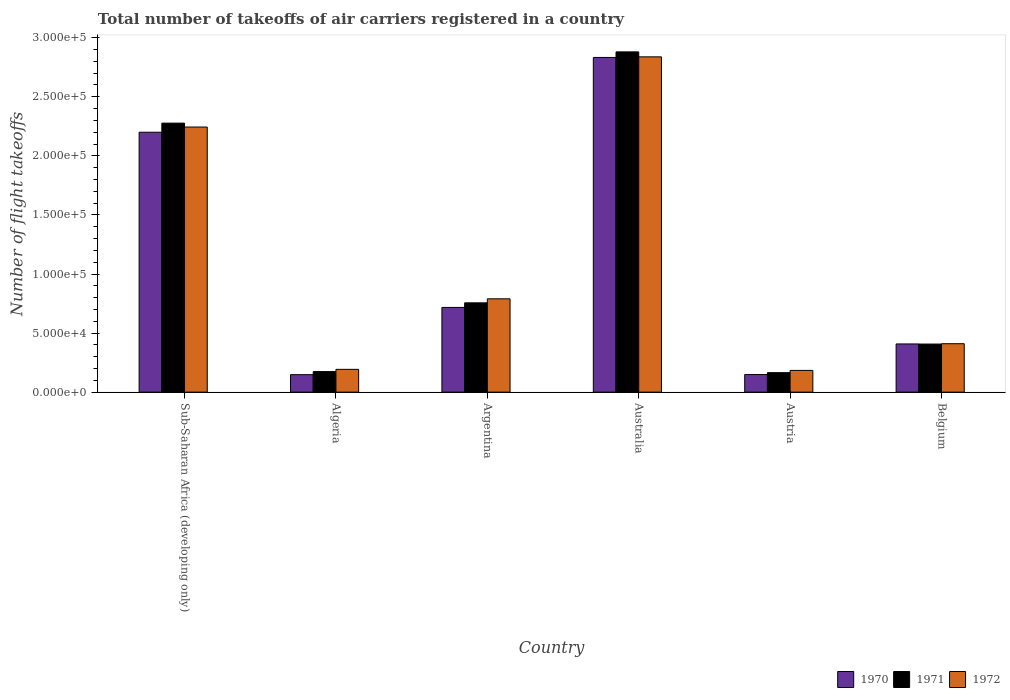How many different coloured bars are there?
Offer a terse response. 3. How many bars are there on the 1st tick from the left?
Provide a succinct answer. 3. What is the label of the 2nd group of bars from the left?
Ensure brevity in your answer.  Algeria. In how many cases, is the number of bars for a given country not equal to the number of legend labels?
Ensure brevity in your answer.  0. What is the total number of flight takeoffs in 1970 in Austria?
Your response must be concise. 1.49e+04. Across all countries, what is the maximum total number of flight takeoffs in 1972?
Ensure brevity in your answer.  2.84e+05. Across all countries, what is the minimum total number of flight takeoffs in 1971?
Make the answer very short. 1.65e+04. In which country was the total number of flight takeoffs in 1971 maximum?
Provide a short and direct response. Australia. What is the total total number of flight takeoffs in 1972 in the graph?
Your answer should be very brief. 6.66e+05. What is the difference between the total number of flight takeoffs in 1970 in Argentina and that in Belgium?
Provide a short and direct response. 3.09e+04. What is the difference between the total number of flight takeoffs in 1970 in Sub-Saharan Africa (developing only) and the total number of flight takeoffs in 1971 in Austria?
Offer a very short reply. 2.04e+05. What is the average total number of flight takeoffs in 1970 per country?
Provide a succinct answer. 1.08e+05. What is the difference between the total number of flight takeoffs of/in 1972 and total number of flight takeoffs of/in 1971 in Argentina?
Your answer should be compact. 3400. What is the ratio of the total number of flight takeoffs in 1971 in Argentina to that in Belgium?
Provide a short and direct response. 1.86. Is the total number of flight takeoffs in 1970 in Australia less than that in Belgium?
Ensure brevity in your answer.  No. What is the difference between the highest and the second highest total number of flight takeoffs in 1972?
Provide a succinct answer. 5.94e+04. What is the difference between the highest and the lowest total number of flight takeoffs in 1970?
Offer a very short reply. 2.68e+05. In how many countries, is the total number of flight takeoffs in 1972 greater than the average total number of flight takeoffs in 1972 taken over all countries?
Give a very brief answer. 2. Is the sum of the total number of flight takeoffs in 1971 in Australia and Belgium greater than the maximum total number of flight takeoffs in 1972 across all countries?
Offer a very short reply. Yes. Are all the bars in the graph horizontal?
Ensure brevity in your answer.  No. Does the graph contain any zero values?
Provide a short and direct response. No. Does the graph contain grids?
Make the answer very short. No. Where does the legend appear in the graph?
Your response must be concise. Bottom right. How are the legend labels stacked?
Offer a terse response. Horizontal. What is the title of the graph?
Give a very brief answer. Total number of takeoffs of air carriers registered in a country. What is the label or title of the X-axis?
Provide a short and direct response. Country. What is the label or title of the Y-axis?
Make the answer very short. Number of flight takeoffs. What is the Number of flight takeoffs of 1970 in Sub-Saharan Africa (developing only)?
Your answer should be compact. 2.20e+05. What is the Number of flight takeoffs of 1971 in Sub-Saharan Africa (developing only)?
Offer a very short reply. 2.28e+05. What is the Number of flight takeoffs of 1972 in Sub-Saharan Africa (developing only)?
Your answer should be very brief. 2.24e+05. What is the Number of flight takeoffs in 1970 in Algeria?
Ensure brevity in your answer.  1.48e+04. What is the Number of flight takeoffs in 1971 in Algeria?
Offer a very short reply. 1.74e+04. What is the Number of flight takeoffs of 1972 in Algeria?
Give a very brief answer. 1.93e+04. What is the Number of flight takeoffs of 1970 in Argentina?
Keep it short and to the point. 7.17e+04. What is the Number of flight takeoffs of 1971 in Argentina?
Provide a succinct answer. 7.56e+04. What is the Number of flight takeoffs of 1972 in Argentina?
Your answer should be very brief. 7.90e+04. What is the Number of flight takeoffs of 1970 in Australia?
Make the answer very short. 2.83e+05. What is the Number of flight takeoffs of 1971 in Australia?
Provide a succinct answer. 2.88e+05. What is the Number of flight takeoffs of 1972 in Australia?
Provide a short and direct response. 2.84e+05. What is the Number of flight takeoffs of 1970 in Austria?
Provide a succinct answer. 1.49e+04. What is the Number of flight takeoffs in 1971 in Austria?
Your answer should be very brief. 1.65e+04. What is the Number of flight takeoffs of 1972 in Austria?
Provide a short and direct response. 1.84e+04. What is the Number of flight takeoffs of 1970 in Belgium?
Keep it short and to the point. 4.08e+04. What is the Number of flight takeoffs in 1971 in Belgium?
Your response must be concise. 4.07e+04. What is the Number of flight takeoffs of 1972 in Belgium?
Ensure brevity in your answer.  4.10e+04. Across all countries, what is the maximum Number of flight takeoffs in 1970?
Give a very brief answer. 2.83e+05. Across all countries, what is the maximum Number of flight takeoffs in 1971?
Ensure brevity in your answer.  2.88e+05. Across all countries, what is the maximum Number of flight takeoffs of 1972?
Give a very brief answer. 2.84e+05. Across all countries, what is the minimum Number of flight takeoffs in 1970?
Make the answer very short. 1.48e+04. Across all countries, what is the minimum Number of flight takeoffs in 1971?
Offer a very short reply. 1.65e+04. Across all countries, what is the minimum Number of flight takeoffs in 1972?
Your answer should be compact. 1.84e+04. What is the total Number of flight takeoffs in 1970 in the graph?
Offer a very short reply. 6.46e+05. What is the total Number of flight takeoffs of 1971 in the graph?
Your answer should be very brief. 6.66e+05. What is the total Number of flight takeoffs in 1972 in the graph?
Provide a succinct answer. 6.66e+05. What is the difference between the Number of flight takeoffs of 1970 in Sub-Saharan Africa (developing only) and that in Algeria?
Provide a succinct answer. 2.05e+05. What is the difference between the Number of flight takeoffs in 1971 in Sub-Saharan Africa (developing only) and that in Algeria?
Offer a terse response. 2.10e+05. What is the difference between the Number of flight takeoffs in 1972 in Sub-Saharan Africa (developing only) and that in Algeria?
Give a very brief answer. 2.05e+05. What is the difference between the Number of flight takeoffs of 1970 in Sub-Saharan Africa (developing only) and that in Argentina?
Give a very brief answer. 1.48e+05. What is the difference between the Number of flight takeoffs in 1971 in Sub-Saharan Africa (developing only) and that in Argentina?
Your response must be concise. 1.52e+05. What is the difference between the Number of flight takeoffs of 1972 in Sub-Saharan Africa (developing only) and that in Argentina?
Make the answer very short. 1.45e+05. What is the difference between the Number of flight takeoffs of 1970 in Sub-Saharan Africa (developing only) and that in Australia?
Give a very brief answer. -6.33e+04. What is the difference between the Number of flight takeoffs of 1971 in Sub-Saharan Africa (developing only) and that in Australia?
Offer a very short reply. -6.03e+04. What is the difference between the Number of flight takeoffs of 1972 in Sub-Saharan Africa (developing only) and that in Australia?
Provide a short and direct response. -5.94e+04. What is the difference between the Number of flight takeoffs in 1970 in Sub-Saharan Africa (developing only) and that in Austria?
Make the answer very short. 2.05e+05. What is the difference between the Number of flight takeoffs in 1971 in Sub-Saharan Africa (developing only) and that in Austria?
Your answer should be very brief. 2.11e+05. What is the difference between the Number of flight takeoffs in 1972 in Sub-Saharan Africa (developing only) and that in Austria?
Your answer should be very brief. 2.06e+05. What is the difference between the Number of flight takeoffs of 1970 in Sub-Saharan Africa (developing only) and that in Belgium?
Your response must be concise. 1.79e+05. What is the difference between the Number of flight takeoffs of 1971 in Sub-Saharan Africa (developing only) and that in Belgium?
Make the answer very short. 1.87e+05. What is the difference between the Number of flight takeoffs in 1972 in Sub-Saharan Africa (developing only) and that in Belgium?
Your answer should be very brief. 1.83e+05. What is the difference between the Number of flight takeoffs of 1970 in Algeria and that in Argentina?
Provide a succinct answer. -5.69e+04. What is the difference between the Number of flight takeoffs in 1971 in Algeria and that in Argentina?
Ensure brevity in your answer.  -5.82e+04. What is the difference between the Number of flight takeoffs in 1972 in Algeria and that in Argentina?
Ensure brevity in your answer.  -5.97e+04. What is the difference between the Number of flight takeoffs of 1970 in Algeria and that in Australia?
Your answer should be very brief. -2.68e+05. What is the difference between the Number of flight takeoffs of 1971 in Algeria and that in Australia?
Your answer should be compact. -2.71e+05. What is the difference between the Number of flight takeoffs in 1972 in Algeria and that in Australia?
Your response must be concise. -2.64e+05. What is the difference between the Number of flight takeoffs of 1970 in Algeria and that in Austria?
Your answer should be compact. -100. What is the difference between the Number of flight takeoffs in 1971 in Algeria and that in Austria?
Provide a succinct answer. 900. What is the difference between the Number of flight takeoffs of 1972 in Algeria and that in Austria?
Keep it short and to the point. 900. What is the difference between the Number of flight takeoffs in 1970 in Algeria and that in Belgium?
Ensure brevity in your answer.  -2.60e+04. What is the difference between the Number of flight takeoffs in 1971 in Algeria and that in Belgium?
Your answer should be compact. -2.33e+04. What is the difference between the Number of flight takeoffs of 1972 in Algeria and that in Belgium?
Offer a terse response. -2.17e+04. What is the difference between the Number of flight takeoffs of 1970 in Argentina and that in Australia?
Keep it short and to the point. -2.12e+05. What is the difference between the Number of flight takeoffs of 1971 in Argentina and that in Australia?
Provide a short and direct response. -2.12e+05. What is the difference between the Number of flight takeoffs in 1972 in Argentina and that in Australia?
Ensure brevity in your answer.  -2.05e+05. What is the difference between the Number of flight takeoffs in 1970 in Argentina and that in Austria?
Provide a short and direct response. 5.68e+04. What is the difference between the Number of flight takeoffs of 1971 in Argentina and that in Austria?
Offer a terse response. 5.91e+04. What is the difference between the Number of flight takeoffs in 1972 in Argentina and that in Austria?
Provide a succinct answer. 6.06e+04. What is the difference between the Number of flight takeoffs in 1970 in Argentina and that in Belgium?
Keep it short and to the point. 3.09e+04. What is the difference between the Number of flight takeoffs in 1971 in Argentina and that in Belgium?
Ensure brevity in your answer.  3.49e+04. What is the difference between the Number of flight takeoffs of 1972 in Argentina and that in Belgium?
Keep it short and to the point. 3.80e+04. What is the difference between the Number of flight takeoffs of 1970 in Australia and that in Austria?
Keep it short and to the point. 2.68e+05. What is the difference between the Number of flight takeoffs of 1971 in Australia and that in Austria?
Offer a terse response. 2.72e+05. What is the difference between the Number of flight takeoffs in 1972 in Australia and that in Austria?
Your answer should be very brief. 2.65e+05. What is the difference between the Number of flight takeoffs in 1970 in Australia and that in Belgium?
Make the answer very short. 2.42e+05. What is the difference between the Number of flight takeoffs of 1971 in Australia and that in Belgium?
Provide a short and direct response. 2.47e+05. What is the difference between the Number of flight takeoffs of 1972 in Australia and that in Belgium?
Provide a short and direct response. 2.43e+05. What is the difference between the Number of flight takeoffs of 1970 in Austria and that in Belgium?
Your response must be concise. -2.59e+04. What is the difference between the Number of flight takeoffs of 1971 in Austria and that in Belgium?
Offer a terse response. -2.42e+04. What is the difference between the Number of flight takeoffs in 1972 in Austria and that in Belgium?
Offer a terse response. -2.26e+04. What is the difference between the Number of flight takeoffs of 1970 in Sub-Saharan Africa (developing only) and the Number of flight takeoffs of 1971 in Algeria?
Offer a very short reply. 2.03e+05. What is the difference between the Number of flight takeoffs of 1970 in Sub-Saharan Africa (developing only) and the Number of flight takeoffs of 1972 in Algeria?
Ensure brevity in your answer.  2.01e+05. What is the difference between the Number of flight takeoffs of 1971 in Sub-Saharan Africa (developing only) and the Number of flight takeoffs of 1972 in Algeria?
Offer a very short reply. 2.08e+05. What is the difference between the Number of flight takeoffs in 1970 in Sub-Saharan Africa (developing only) and the Number of flight takeoffs in 1971 in Argentina?
Your answer should be compact. 1.44e+05. What is the difference between the Number of flight takeoffs in 1970 in Sub-Saharan Africa (developing only) and the Number of flight takeoffs in 1972 in Argentina?
Give a very brief answer. 1.41e+05. What is the difference between the Number of flight takeoffs in 1971 in Sub-Saharan Africa (developing only) and the Number of flight takeoffs in 1972 in Argentina?
Your answer should be very brief. 1.49e+05. What is the difference between the Number of flight takeoffs of 1970 in Sub-Saharan Africa (developing only) and the Number of flight takeoffs of 1971 in Australia?
Ensure brevity in your answer.  -6.80e+04. What is the difference between the Number of flight takeoffs in 1970 in Sub-Saharan Africa (developing only) and the Number of flight takeoffs in 1972 in Australia?
Keep it short and to the point. -6.38e+04. What is the difference between the Number of flight takeoffs in 1971 in Sub-Saharan Africa (developing only) and the Number of flight takeoffs in 1972 in Australia?
Your answer should be compact. -5.61e+04. What is the difference between the Number of flight takeoffs of 1970 in Sub-Saharan Africa (developing only) and the Number of flight takeoffs of 1971 in Austria?
Offer a terse response. 2.04e+05. What is the difference between the Number of flight takeoffs in 1970 in Sub-Saharan Africa (developing only) and the Number of flight takeoffs in 1972 in Austria?
Keep it short and to the point. 2.02e+05. What is the difference between the Number of flight takeoffs in 1971 in Sub-Saharan Africa (developing only) and the Number of flight takeoffs in 1972 in Austria?
Make the answer very short. 2.09e+05. What is the difference between the Number of flight takeoffs of 1970 in Sub-Saharan Africa (developing only) and the Number of flight takeoffs of 1971 in Belgium?
Provide a short and direct response. 1.79e+05. What is the difference between the Number of flight takeoffs of 1970 in Sub-Saharan Africa (developing only) and the Number of flight takeoffs of 1972 in Belgium?
Provide a short and direct response. 1.79e+05. What is the difference between the Number of flight takeoffs of 1971 in Sub-Saharan Africa (developing only) and the Number of flight takeoffs of 1972 in Belgium?
Provide a succinct answer. 1.87e+05. What is the difference between the Number of flight takeoffs of 1970 in Algeria and the Number of flight takeoffs of 1971 in Argentina?
Your answer should be very brief. -6.08e+04. What is the difference between the Number of flight takeoffs of 1970 in Algeria and the Number of flight takeoffs of 1972 in Argentina?
Provide a short and direct response. -6.42e+04. What is the difference between the Number of flight takeoffs of 1971 in Algeria and the Number of flight takeoffs of 1972 in Argentina?
Make the answer very short. -6.16e+04. What is the difference between the Number of flight takeoffs in 1970 in Algeria and the Number of flight takeoffs in 1971 in Australia?
Make the answer very short. -2.73e+05. What is the difference between the Number of flight takeoffs in 1970 in Algeria and the Number of flight takeoffs in 1972 in Australia?
Keep it short and to the point. -2.69e+05. What is the difference between the Number of flight takeoffs of 1971 in Algeria and the Number of flight takeoffs of 1972 in Australia?
Give a very brief answer. -2.66e+05. What is the difference between the Number of flight takeoffs of 1970 in Algeria and the Number of flight takeoffs of 1971 in Austria?
Provide a succinct answer. -1700. What is the difference between the Number of flight takeoffs in 1970 in Algeria and the Number of flight takeoffs in 1972 in Austria?
Your response must be concise. -3600. What is the difference between the Number of flight takeoffs in 1971 in Algeria and the Number of flight takeoffs in 1972 in Austria?
Keep it short and to the point. -1000. What is the difference between the Number of flight takeoffs of 1970 in Algeria and the Number of flight takeoffs of 1971 in Belgium?
Give a very brief answer. -2.59e+04. What is the difference between the Number of flight takeoffs in 1970 in Algeria and the Number of flight takeoffs in 1972 in Belgium?
Provide a succinct answer. -2.62e+04. What is the difference between the Number of flight takeoffs of 1971 in Algeria and the Number of flight takeoffs of 1972 in Belgium?
Your answer should be compact. -2.36e+04. What is the difference between the Number of flight takeoffs in 1970 in Argentina and the Number of flight takeoffs in 1971 in Australia?
Offer a terse response. -2.16e+05. What is the difference between the Number of flight takeoffs of 1970 in Argentina and the Number of flight takeoffs of 1972 in Australia?
Give a very brief answer. -2.12e+05. What is the difference between the Number of flight takeoffs of 1971 in Argentina and the Number of flight takeoffs of 1972 in Australia?
Offer a terse response. -2.08e+05. What is the difference between the Number of flight takeoffs of 1970 in Argentina and the Number of flight takeoffs of 1971 in Austria?
Your answer should be compact. 5.52e+04. What is the difference between the Number of flight takeoffs of 1970 in Argentina and the Number of flight takeoffs of 1972 in Austria?
Your answer should be very brief. 5.33e+04. What is the difference between the Number of flight takeoffs of 1971 in Argentina and the Number of flight takeoffs of 1972 in Austria?
Offer a very short reply. 5.72e+04. What is the difference between the Number of flight takeoffs in 1970 in Argentina and the Number of flight takeoffs in 1971 in Belgium?
Your response must be concise. 3.10e+04. What is the difference between the Number of flight takeoffs in 1970 in Argentina and the Number of flight takeoffs in 1972 in Belgium?
Provide a succinct answer. 3.07e+04. What is the difference between the Number of flight takeoffs of 1971 in Argentina and the Number of flight takeoffs of 1972 in Belgium?
Your answer should be compact. 3.46e+04. What is the difference between the Number of flight takeoffs of 1970 in Australia and the Number of flight takeoffs of 1971 in Austria?
Make the answer very short. 2.67e+05. What is the difference between the Number of flight takeoffs in 1970 in Australia and the Number of flight takeoffs in 1972 in Austria?
Give a very brief answer. 2.65e+05. What is the difference between the Number of flight takeoffs in 1971 in Australia and the Number of flight takeoffs in 1972 in Austria?
Offer a terse response. 2.70e+05. What is the difference between the Number of flight takeoffs in 1970 in Australia and the Number of flight takeoffs in 1971 in Belgium?
Give a very brief answer. 2.43e+05. What is the difference between the Number of flight takeoffs of 1970 in Australia and the Number of flight takeoffs of 1972 in Belgium?
Your answer should be very brief. 2.42e+05. What is the difference between the Number of flight takeoffs of 1971 in Australia and the Number of flight takeoffs of 1972 in Belgium?
Ensure brevity in your answer.  2.47e+05. What is the difference between the Number of flight takeoffs in 1970 in Austria and the Number of flight takeoffs in 1971 in Belgium?
Provide a succinct answer. -2.58e+04. What is the difference between the Number of flight takeoffs of 1970 in Austria and the Number of flight takeoffs of 1972 in Belgium?
Offer a terse response. -2.61e+04. What is the difference between the Number of flight takeoffs of 1971 in Austria and the Number of flight takeoffs of 1972 in Belgium?
Make the answer very short. -2.45e+04. What is the average Number of flight takeoffs of 1970 per country?
Keep it short and to the point. 1.08e+05. What is the average Number of flight takeoffs in 1971 per country?
Keep it short and to the point. 1.11e+05. What is the average Number of flight takeoffs in 1972 per country?
Provide a succinct answer. 1.11e+05. What is the difference between the Number of flight takeoffs of 1970 and Number of flight takeoffs of 1971 in Sub-Saharan Africa (developing only)?
Make the answer very short. -7700. What is the difference between the Number of flight takeoffs in 1970 and Number of flight takeoffs in 1972 in Sub-Saharan Africa (developing only)?
Your answer should be compact. -4400. What is the difference between the Number of flight takeoffs in 1971 and Number of flight takeoffs in 1972 in Sub-Saharan Africa (developing only)?
Offer a very short reply. 3300. What is the difference between the Number of flight takeoffs in 1970 and Number of flight takeoffs in 1971 in Algeria?
Provide a short and direct response. -2600. What is the difference between the Number of flight takeoffs of 1970 and Number of flight takeoffs of 1972 in Algeria?
Provide a short and direct response. -4500. What is the difference between the Number of flight takeoffs in 1971 and Number of flight takeoffs in 1972 in Algeria?
Your answer should be very brief. -1900. What is the difference between the Number of flight takeoffs of 1970 and Number of flight takeoffs of 1971 in Argentina?
Keep it short and to the point. -3900. What is the difference between the Number of flight takeoffs of 1970 and Number of flight takeoffs of 1972 in Argentina?
Your answer should be very brief. -7300. What is the difference between the Number of flight takeoffs of 1971 and Number of flight takeoffs of 1972 in Argentina?
Your response must be concise. -3400. What is the difference between the Number of flight takeoffs of 1970 and Number of flight takeoffs of 1971 in Australia?
Your response must be concise. -4700. What is the difference between the Number of flight takeoffs in 1970 and Number of flight takeoffs in 1972 in Australia?
Keep it short and to the point. -500. What is the difference between the Number of flight takeoffs of 1971 and Number of flight takeoffs of 1972 in Australia?
Your answer should be very brief. 4200. What is the difference between the Number of flight takeoffs in 1970 and Number of flight takeoffs in 1971 in Austria?
Your response must be concise. -1600. What is the difference between the Number of flight takeoffs in 1970 and Number of flight takeoffs in 1972 in Austria?
Offer a terse response. -3500. What is the difference between the Number of flight takeoffs of 1971 and Number of flight takeoffs of 1972 in Austria?
Your answer should be compact. -1900. What is the difference between the Number of flight takeoffs of 1970 and Number of flight takeoffs of 1972 in Belgium?
Your answer should be very brief. -200. What is the difference between the Number of flight takeoffs in 1971 and Number of flight takeoffs in 1972 in Belgium?
Keep it short and to the point. -300. What is the ratio of the Number of flight takeoffs of 1970 in Sub-Saharan Africa (developing only) to that in Algeria?
Your answer should be very brief. 14.86. What is the ratio of the Number of flight takeoffs of 1971 in Sub-Saharan Africa (developing only) to that in Algeria?
Provide a short and direct response. 13.09. What is the ratio of the Number of flight takeoffs of 1972 in Sub-Saharan Africa (developing only) to that in Algeria?
Offer a terse response. 11.63. What is the ratio of the Number of flight takeoffs in 1970 in Sub-Saharan Africa (developing only) to that in Argentina?
Offer a very short reply. 3.07. What is the ratio of the Number of flight takeoffs of 1971 in Sub-Saharan Africa (developing only) to that in Argentina?
Ensure brevity in your answer.  3.01. What is the ratio of the Number of flight takeoffs of 1972 in Sub-Saharan Africa (developing only) to that in Argentina?
Provide a succinct answer. 2.84. What is the ratio of the Number of flight takeoffs in 1970 in Sub-Saharan Africa (developing only) to that in Australia?
Offer a very short reply. 0.78. What is the ratio of the Number of flight takeoffs in 1971 in Sub-Saharan Africa (developing only) to that in Australia?
Ensure brevity in your answer.  0.79. What is the ratio of the Number of flight takeoffs in 1972 in Sub-Saharan Africa (developing only) to that in Australia?
Ensure brevity in your answer.  0.79. What is the ratio of the Number of flight takeoffs in 1970 in Sub-Saharan Africa (developing only) to that in Austria?
Offer a very short reply. 14.77. What is the ratio of the Number of flight takeoffs of 1971 in Sub-Saharan Africa (developing only) to that in Austria?
Your response must be concise. 13.8. What is the ratio of the Number of flight takeoffs in 1972 in Sub-Saharan Africa (developing only) to that in Austria?
Offer a very short reply. 12.2. What is the ratio of the Number of flight takeoffs in 1970 in Sub-Saharan Africa (developing only) to that in Belgium?
Your answer should be compact. 5.39. What is the ratio of the Number of flight takeoffs in 1971 in Sub-Saharan Africa (developing only) to that in Belgium?
Make the answer very short. 5.59. What is the ratio of the Number of flight takeoffs of 1972 in Sub-Saharan Africa (developing only) to that in Belgium?
Provide a short and direct response. 5.47. What is the ratio of the Number of flight takeoffs of 1970 in Algeria to that in Argentina?
Ensure brevity in your answer.  0.21. What is the ratio of the Number of flight takeoffs of 1971 in Algeria to that in Argentina?
Provide a short and direct response. 0.23. What is the ratio of the Number of flight takeoffs of 1972 in Algeria to that in Argentina?
Make the answer very short. 0.24. What is the ratio of the Number of flight takeoffs of 1970 in Algeria to that in Australia?
Your answer should be very brief. 0.05. What is the ratio of the Number of flight takeoffs in 1971 in Algeria to that in Australia?
Ensure brevity in your answer.  0.06. What is the ratio of the Number of flight takeoffs of 1972 in Algeria to that in Australia?
Offer a terse response. 0.07. What is the ratio of the Number of flight takeoffs in 1970 in Algeria to that in Austria?
Offer a very short reply. 0.99. What is the ratio of the Number of flight takeoffs of 1971 in Algeria to that in Austria?
Your response must be concise. 1.05. What is the ratio of the Number of flight takeoffs in 1972 in Algeria to that in Austria?
Your response must be concise. 1.05. What is the ratio of the Number of flight takeoffs in 1970 in Algeria to that in Belgium?
Your response must be concise. 0.36. What is the ratio of the Number of flight takeoffs of 1971 in Algeria to that in Belgium?
Offer a very short reply. 0.43. What is the ratio of the Number of flight takeoffs in 1972 in Algeria to that in Belgium?
Your answer should be compact. 0.47. What is the ratio of the Number of flight takeoffs of 1970 in Argentina to that in Australia?
Offer a terse response. 0.25. What is the ratio of the Number of flight takeoffs in 1971 in Argentina to that in Australia?
Your answer should be compact. 0.26. What is the ratio of the Number of flight takeoffs in 1972 in Argentina to that in Australia?
Provide a short and direct response. 0.28. What is the ratio of the Number of flight takeoffs of 1970 in Argentina to that in Austria?
Offer a very short reply. 4.81. What is the ratio of the Number of flight takeoffs in 1971 in Argentina to that in Austria?
Ensure brevity in your answer.  4.58. What is the ratio of the Number of flight takeoffs in 1972 in Argentina to that in Austria?
Offer a very short reply. 4.29. What is the ratio of the Number of flight takeoffs of 1970 in Argentina to that in Belgium?
Give a very brief answer. 1.76. What is the ratio of the Number of flight takeoffs of 1971 in Argentina to that in Belgium?
Make the answer very short. 1.86. What is the ratio of the Number of flight takeoffs in 1972 in Argentina to that in Belgium?
Keep it short and to the point. 1.93. What is the ratio of the Number of flight takeoffs in 1970 in Australia to that in Austria?
Your answer should be compact. 19.01. What is the ratio of the Number of flight takeoffs in 1971 in Australia to that in Austria?
Offer a very short reply. 17.45. What is the ratio of the Number of flight takeoffs in 1972 in Australia to that in Austria?
Your response must be concise. 15.42. What is the ratio of the Number of flight takeoffs in 1970 in Australia to that in Belgium?
Provide a short and direct response. 6.94. What is the ratio of the Number of flight takeoffs in 1971 in Australia to that in Belgium?
Your response must be concise. 7.08. What is the ratio of the Number of flight takeoffs of 1972 in Australia to that in Belgium?
Your answer should be very brief. 6.92. What is the ratio of the Number of flight takeoffs of 1970 in Austria to that in Belgium?
Give a very brief answer. 0.37. What is the ratio of the Number of flight takeoffs in 1971 in Austria to that in Belgium?
Offer a very short reply. 0.41. What is the ratio of the Number of flight takeoffs of 1972 in Austria to that in Belgium?
Provide a succinct answer. 0.45. What is the difference between the highest and the second highest Number of flight takeoffs in 1970?
Your response must be concise. 6.33e+04. What is the difference between the highest and the second highest Number of flight takeoffs in 1971?
Your response must be concise. 6.03e+04. What is the difference between the highest and the second highest Number of flight takeoffs of 1972?
Provide a succinct answer. 5.94e+04. What is the difference between the highest and the lowest Number of flight takeoffs of 1970?
Your answer should be very brief. 2.68e+05. What is the difference between the highest and the lowest Number of flight takeoffs of 1971?
Your answer should be very brief. 2.72e+05. What is the difference between the highest and the lowest Number of flight takeoffs in 1972?
Provide a short and direct response. 2.65e+05. 